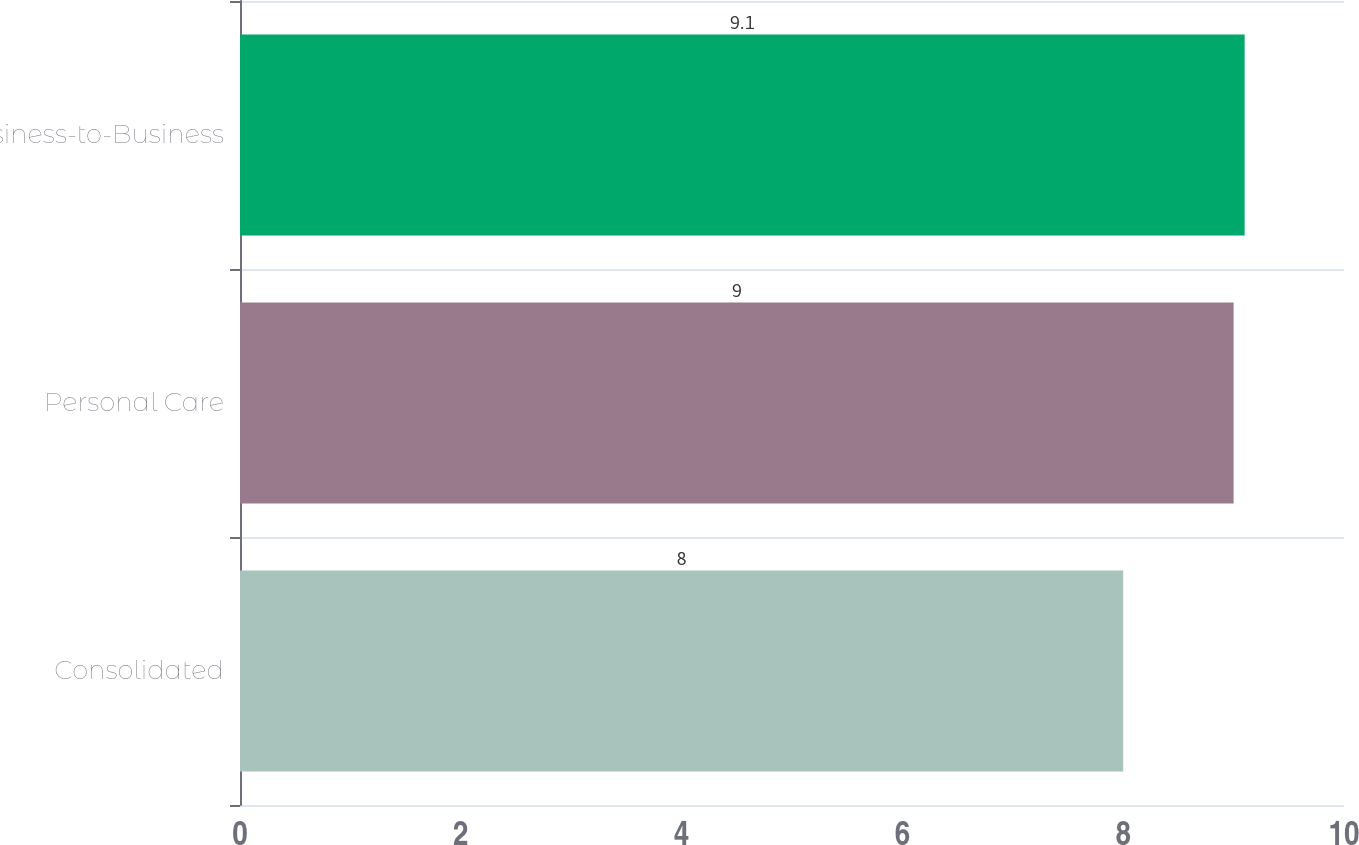<chart> <loc_0><loc_0><loc_500><loc_500><bar_chart><fcel>Consolidated<fcel>Personal Care<fcel>Business-to-Business<nl><fcel>8<fcel>9<fcel>9.1<nl></chart> 